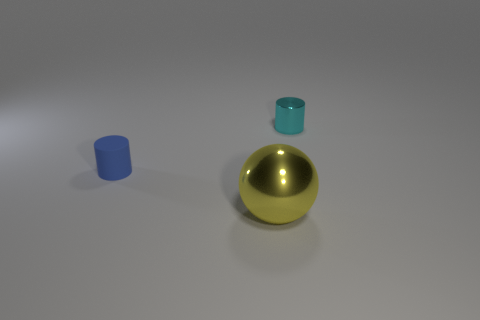Add 3 yellow metallic cylinders. How many objects exist? 6 Subtract all cylinders. How many objects are left? 1 Subtract all green spheres. How many blue cylinders are left? 1 Subtract all tiny blue cylinders. Subtract all yellow shiny spheres. How many objects are left? 1 Add 1 balls. How many balls are left? 2 Add 2 blue cylinders. How many blue cylinders exist? 3 Subtract 1 yellow spheres. How many objects are left? 2 Subtract all brown cylinders. Subtract all blue balls. How many cylinders are left? 2 